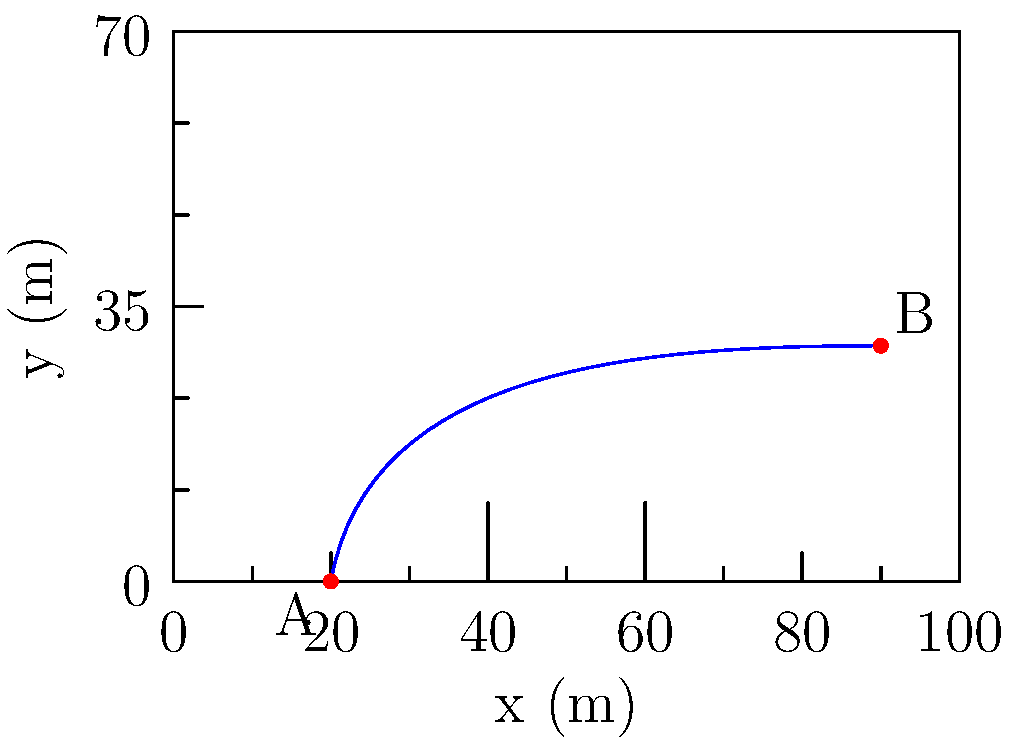As a soccer analyst, you're analyzing a curved free kick. The kick starts at point A (20m, 0m) and ends at point B (90m, 30m). Assuming the trajectory can be approximated by a quadratic function, what is the maximum height reached by the ball during its flight? To solve this problem, we'll follow these steps:

1) The general form of a quadratic function is $y = ax^2 + bx + c$

2) We know two points on this curve:
   A(20, 0) and B(90, 30)

3) Substituting these points into the quadratic equation:
   0 = 400a + 20b + c  (for point A)
   30 = 8100a + 90b + c  (for point B)

4) We need a third equation. We can use the fact that the curve passes through (20, 0):
   $\frac{dy}{dx} = 0$ at x = 20 (the starting point)
   $\frac{dy}{dx} = 2ax + b = 0$ at x = 20
   40a + b = 0

5) Now we have a system of three equations:
   400a + 20b + c = 0
   8100a + 90b + c = 30
   40a + b = 0

6) Solving this system (you can use substitution or matrix methods):
   a = -0.015625
   b = 0.625
   c = -6.25

7) So the quadratic function is:
   $y = -0.015625x^2 + 0.625x - 6.25$

8) To find the maximum height, we need to find the vertex of this parabola.
   The x-coordinate of the vertex is given by $x = -\frac{b}{2a}$:
   
   $x = -\frac{0.625}{2(-0.015625)} = 20$

9) Substituting this x-value back into our quadratic equation:
   $y = -0.015625(20)^2 + 0.625(20) - 6.25 = 6.25$

Therefore, the maximum height reached by the ball is 6.25 meters.
Answer: 6.25 meters 